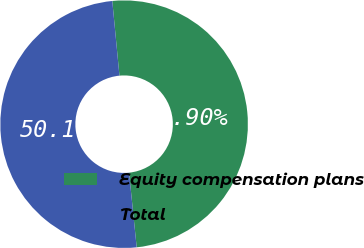Convert chart. <chart><loc_0><loc_0><loc_500><loc_500><pie_chart><fcel>Equity compensation plans<fcel>Total<nl><fcel>49.9%<fcel>50.1%<nl></chart> 